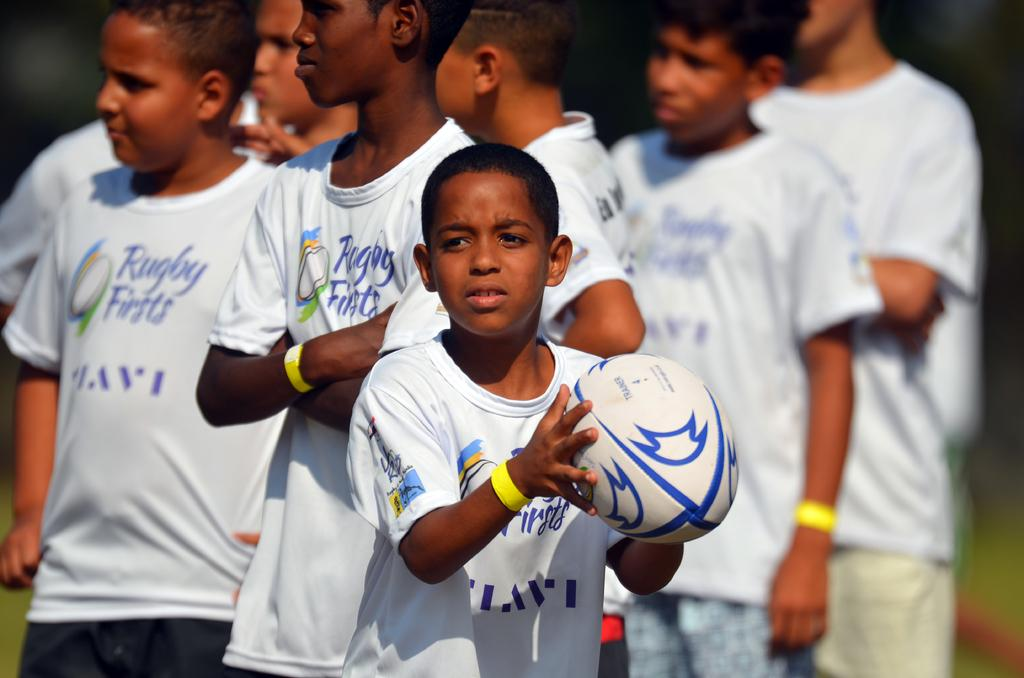<image>
Present a compact description of the photo's key features. soccer players wearing white tshirts saying rugby firsts 